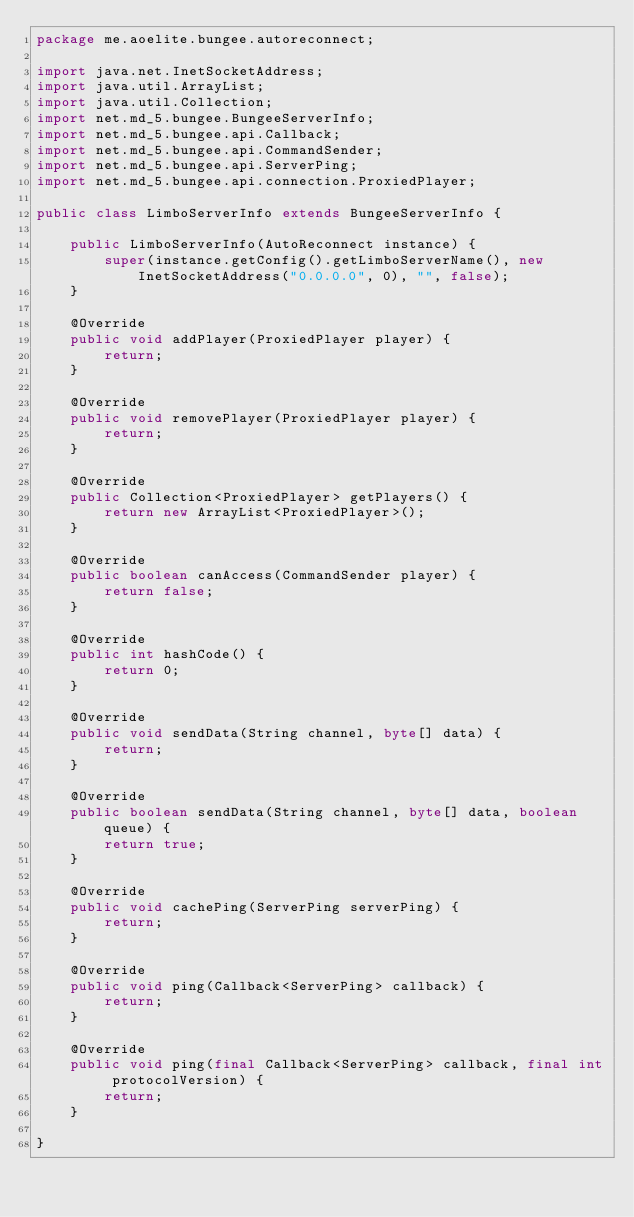<code> <loc_0><loc_0><loc_500><loc_500><_Java_>package me.aoelite.bungee.autoreconnect;

import java.net.InetSocketAddress;
import java.util.ArrayList;
import java.util.Collection;
import net.md_5.bungee.BungeeServerInfo;
import net.md_5.bungee.api.Callback;
import net.md_5.bungee.api.CommandSender;
import net.md_5.bungee.api.ServerPing;
import net.md_5.bungee.api.connection.ProxiedPlayer;

public class LimboServerInfo extends BungeeServerInfo {

	public LimboServerInfo(AutoReconnect instance) {
		super(instance.getConfig().getLimboServerName(), new InetSocketAddress("0.0.0.0", 0), "", false);
	}
	
	@Override
	public void addPlayer(ProxiedPlayer player) {
		return;
	}
	
	@Override
	public void removePlayer(ProxiedPlayer player) {
		return;
	}
	
	@Override
	public Collection<ProxiedPlayer> getPlayers() {
		return new ArrayList<ProxiedPlayer>();
	}
	
	@Override
	public boolean canAccess(CommandSender player) {
		return false;
	}
	
	@Override
	public int hashCode() {
		return 0;
	}
	
	@Override
	public void sendData(String channel, byte[] data) {
		return;
	}
	
	@Override
	public boolean sendData(String channel, byte[] data, boolean queue) {
		return true;
	}
	
	@Override
	public void cachePing(ServerPing serverPing) {
		return;
	}
	
	@Override
	public void ping(Callback<ServerPing> callback) {
		return;
	}
	
	@Override
	public void ping(final Callback<ServerPing> callback, final int protocolVersion) {
		return;
	}

}
</code> 